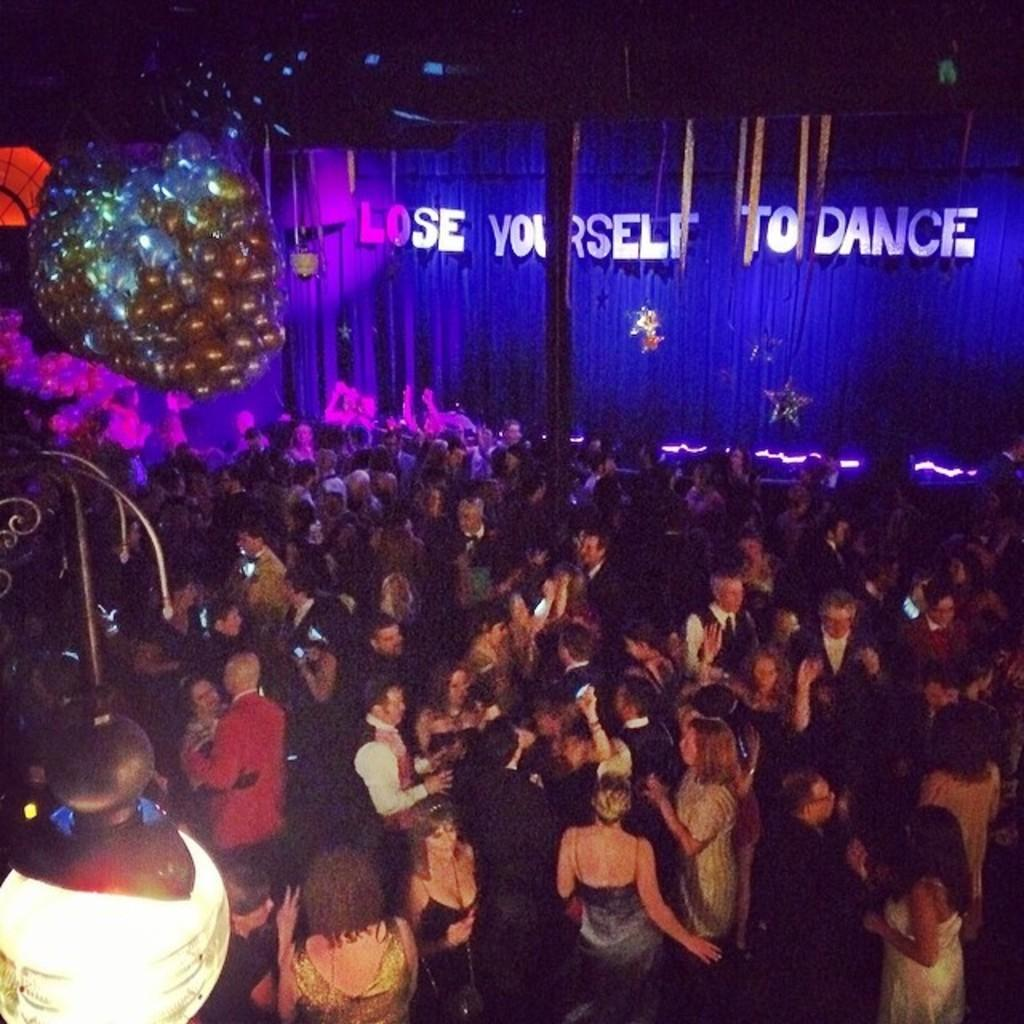How many people are in the image? There is a group of people standing in the image, but the exact number cannot be determined from the provided facts. What object can be seen providing light in the image? There is a lamp in the image. What might be the occasion for the gathering of people in the image? The image may have been taken at a party, as suggested by the presence of a group of people and possibly a festive atmosphere. What type of material is hanging in the image? There is cloth hanging in the image. What structure can be seen supporting the cloth in the image? There is a pole in the image. What is the tendency of the van to park in the image? There is no van present in the image, so it is not possible to determine its tendency to park. 